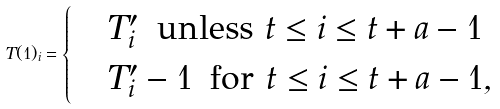<formula> <loc_0><loc_0><loc_500><loc_500>T ( 1 ) _ { i } = \begin{cases} & T ^ { \prime } _ { i } \, \text { unless } t \leq i \leq t + a - 1 \\ & T ^ { \prime } _ { i } - 1 \, \text { for } t \leq i \leq t + a - 1 , \end{cases}</formula> 